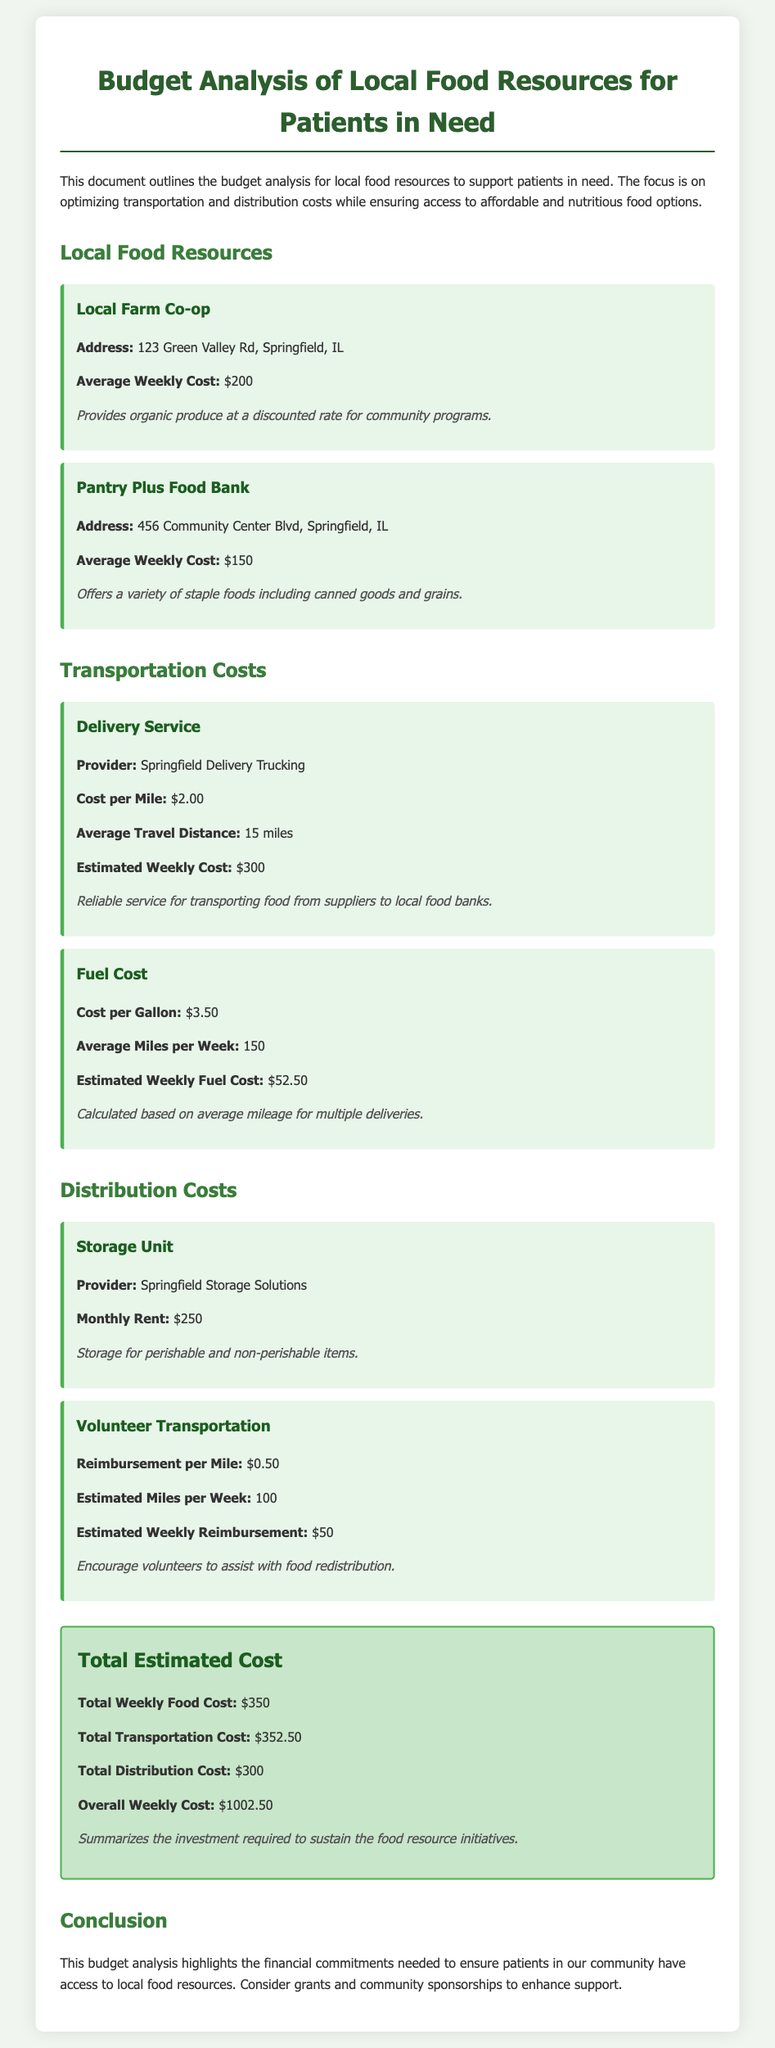What is the address of the Local Farm Co-op? The address is provided under the Local Farm Co-op section in the document.
Answer: 123 Green Valley Rd, Springfield, IL What is the average weekly cost for Pantry Plus Food Bank? The cost is stated in the Pantry Plus Food Bank section of the document.
Answer: $150 What is the provider of the delivery service? The provider is mentioned in the Transportation Costs section of the document.
Answer: Springfield Delivery Trucking What is the cost per mile for the delivery service? This detail is found in the cost item for the delivery service.
Answer: $2.00 How much is the storage unit's monthly rent? The monthly rent is outlined in the Distribution Costs section.
Answer: $250 What is the reimbursement per mile for volunteer transportation? The reimbursement rate is stated in the Volunteer Transportation section of the document.
Answer: $0.50 What is the total weekly food cost? The total is calculated in the Total Estimated Cost section, summarizing the weekly food expenses.
Answer: $350 What is the estimated weekly reimbursement for volunteer transportation? This is detailed in the Volunteer Transportation costs section under the estimated weekly reimbursement.
Answer: $50 What is the overall weekly cost? The overall cost is summarized in the Total Estimated Cost section of the document.
Answer: $1002.50 